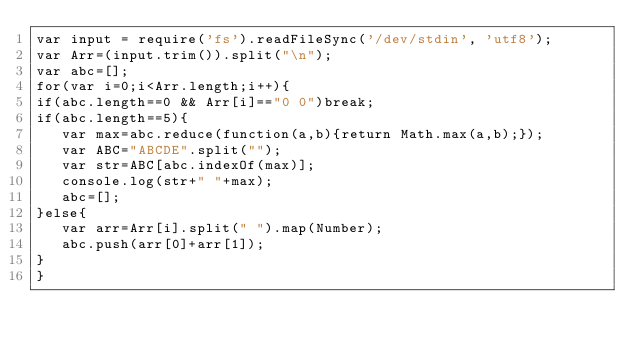<code> <loc_0><loc_0><loc_500><loc_500><_JavaScript_>var input = require('fs').readFileSync('/dev/stdin', 'utf8');
var Arr=(input.trim()).split("\n");
var abc=[];
for(var i=0;i<Arr.length;i++){
if(abc.length==0 && Arr[i]=="0 0")break;
if(abc.length==5){
   var max=abc.reduce(function(a,b){return Math.max(a,b);});
   var ABC="ABCDE".split("");
   var str=ABC[abc.indexOf(max)];
   console.log(str+" "+max);
   abc=[];
}else{
   var arr=Arr[i].split(" ").map(Number);
   abc.push(arr[0]+arr[1]);
}
}</code> 